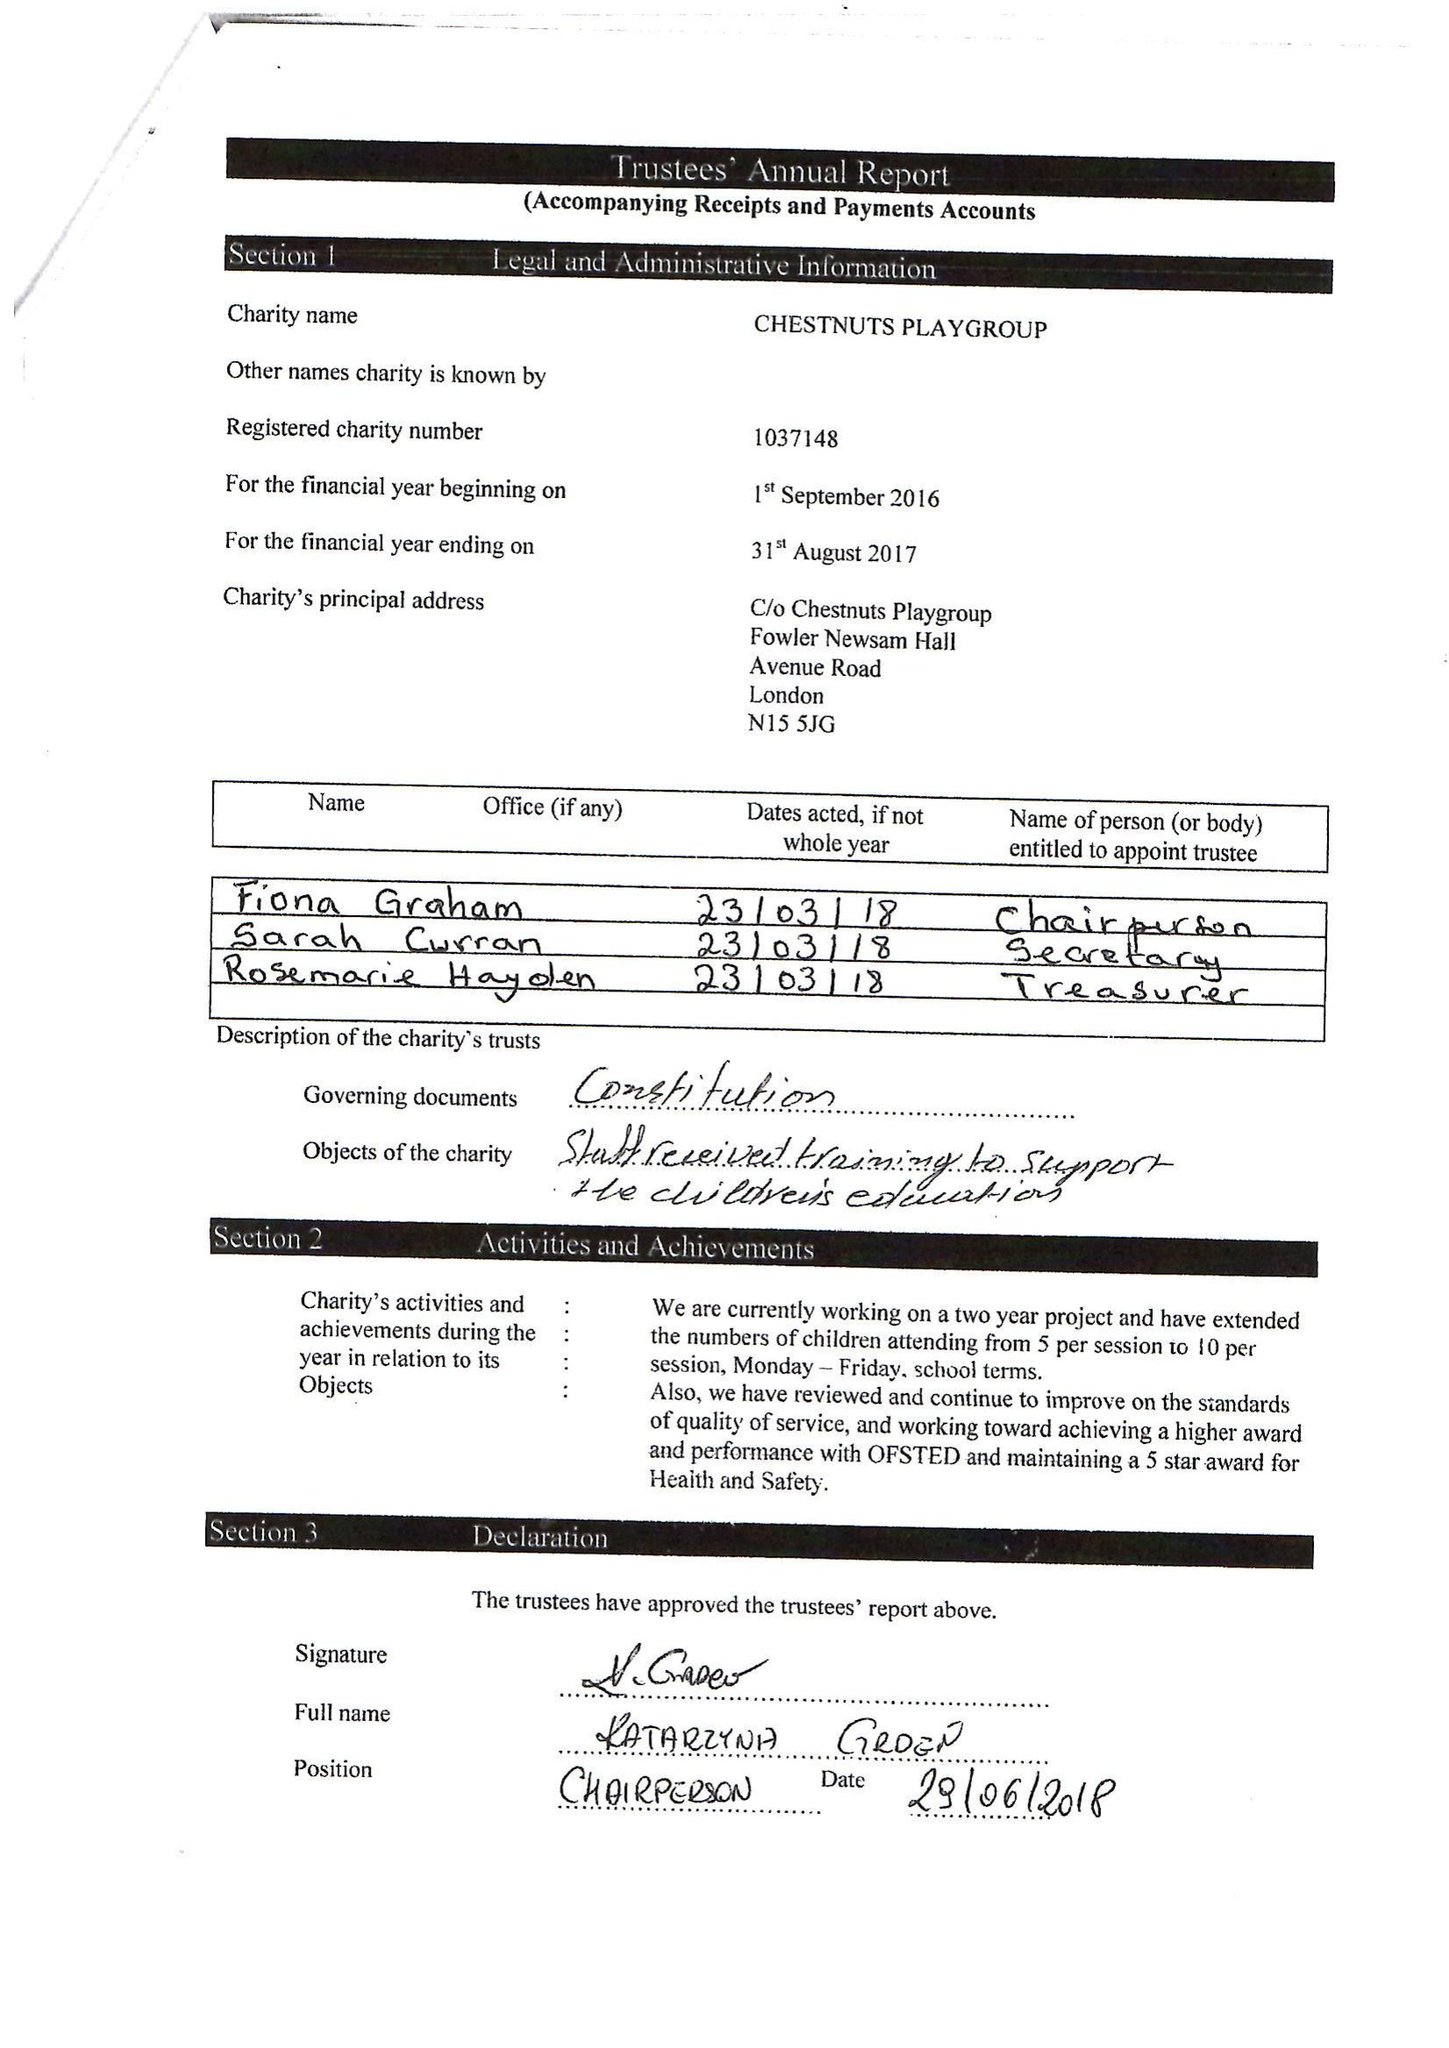What is the value for the address__postcode?
Answer the question using a single word or phrase. N15 5JG 